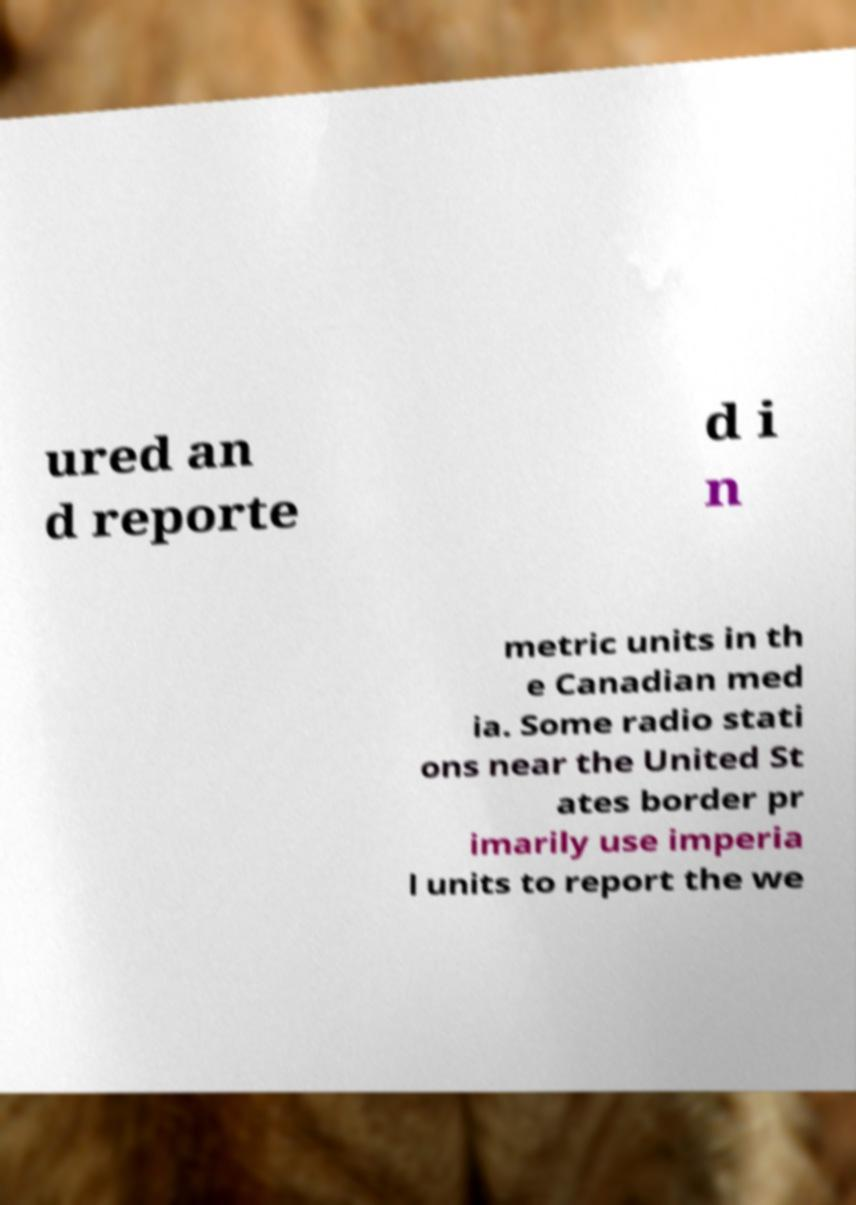I need the written content from this picture converted into text. Can you do that? ured an d reporte d i n metric units in th e Canadian med ia. Some radio stati ons near the United St ates border pr imarily use imperia l units to report the we 